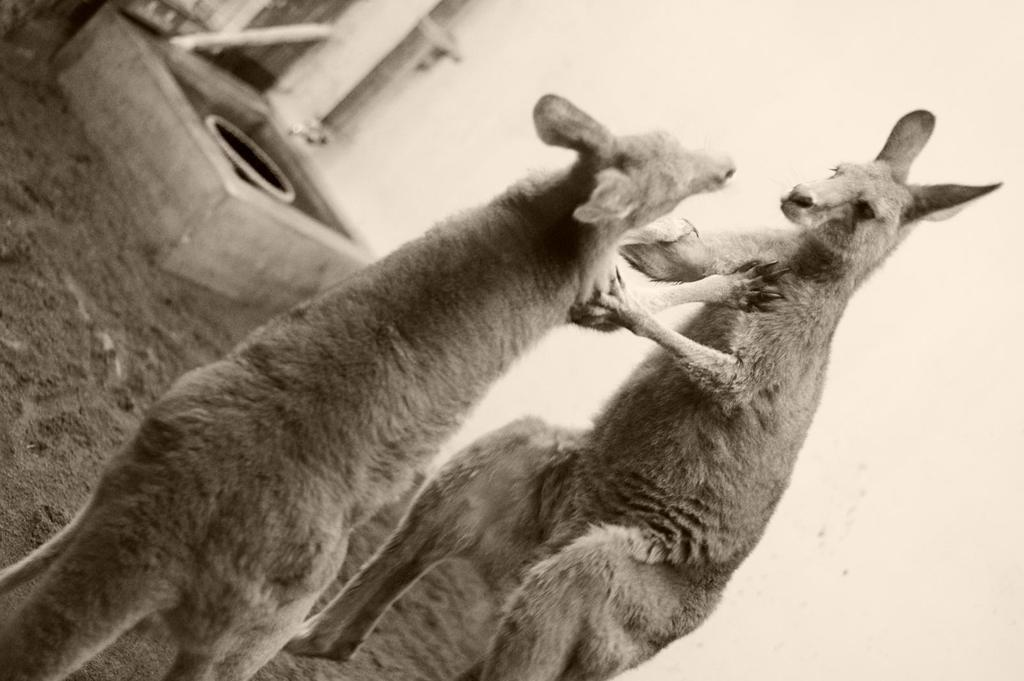What type of animals can be seen in the image? There are animals in the image, but their specific type cannot be determined from the provided facts. What is at the bottom of the image? There is sand visible at the bottom of the image. What can be seen in the background of the image? There is a wall in the background of the image. What type of boot is being worn by the animals in the image? There is no mention of boots or any footwear in the image, and the animals' feet are not visible. 